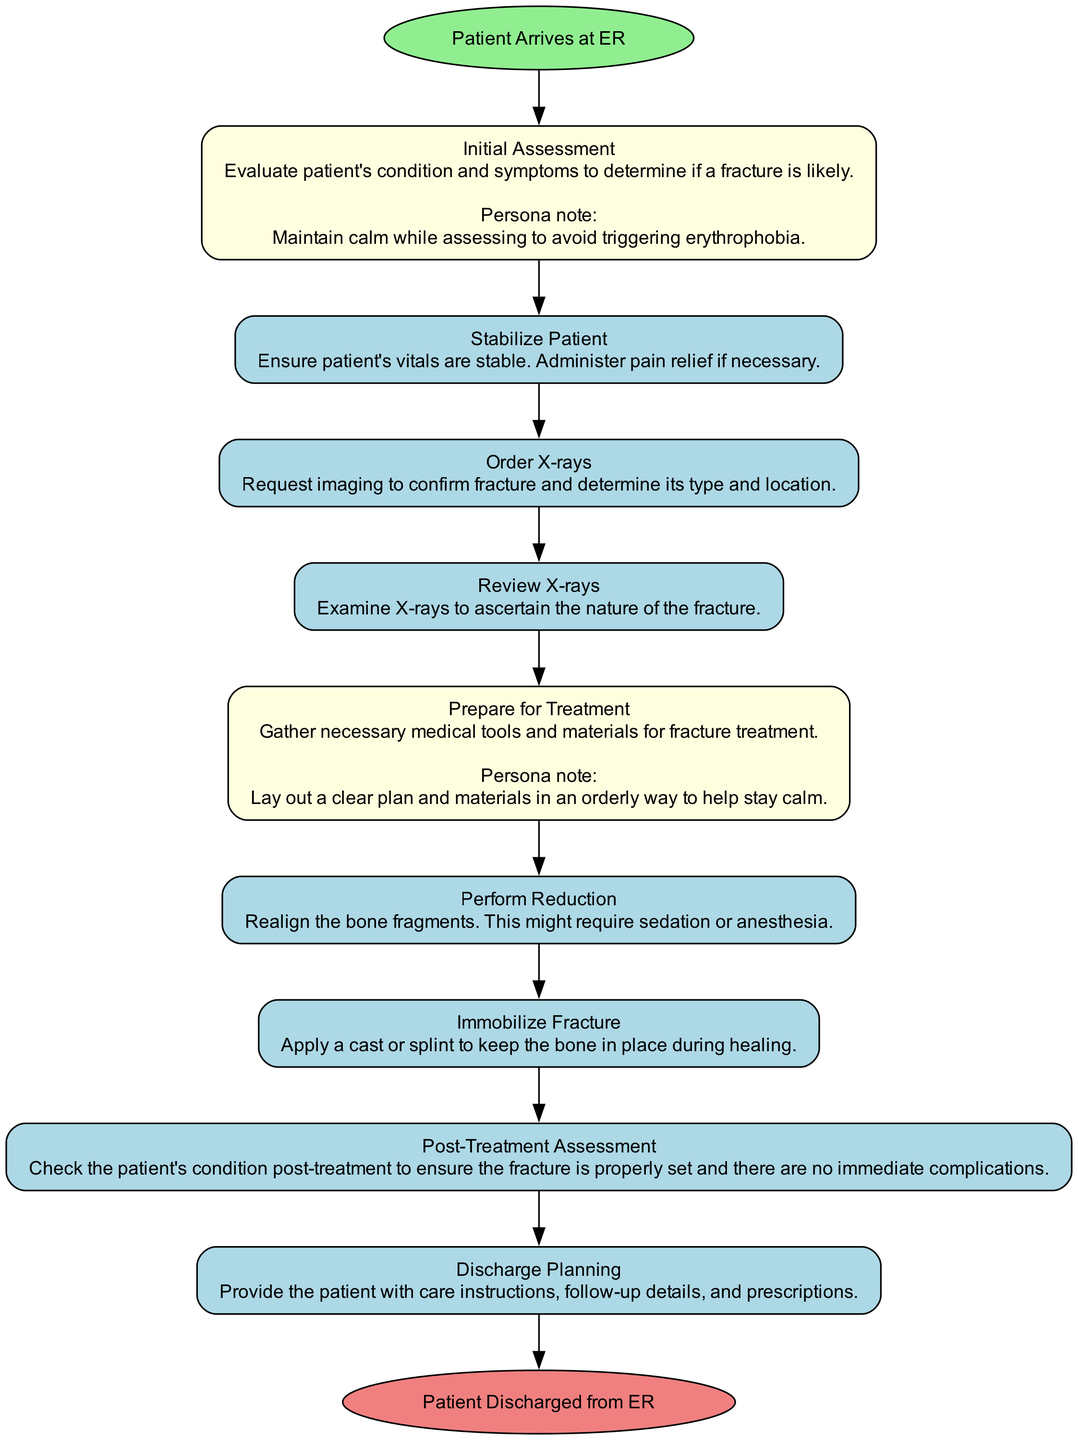What is the first activity in the diagram? The first activity following the start event "Patient Arrives at ER" is "Initial Assessment," which is listed as the first entry in the activities section of the diagram.
Answer: Initial Assessment How many activities are in the diagram? By counting the listed activities in the data provided, there are 9 activities that describe steps in the process, starting from the "Initial Assessment" to "Discharge Planning."
Answer: 9 What follows the "Order X-rays" activity? In the sequence of activities, immediately after "Order X-rays," the next activity is "Review X-rays." This can be determined by looking at the flow from one activity to the next as presented in the data.
Answer: Review X-rays Which activity requires the use of sedation or anesthesia? The "Perform Reduction" activity specifically mentions that it might require sedation or anesthesia. This detail is captured in the description of that activity.
Answer: Perform Reduction What is the final event in the diagram? The last event after all the activities is "Patient Discharged from ER," which concludes the process as indicated by the end event in the diagram.
Answer: Patient Discharged from ER What is the persona relevance of "Prepare for Treatment"? The persona relevance states that it involves laying out a clear plan and materials in an orderly way to help maintain calm. This relevance reflects the importance of staying organized to avoid triggering erythrophobia during treatment preparation.
Answer: Lay out a clear plan and materials in an orderly way to help stay calm 